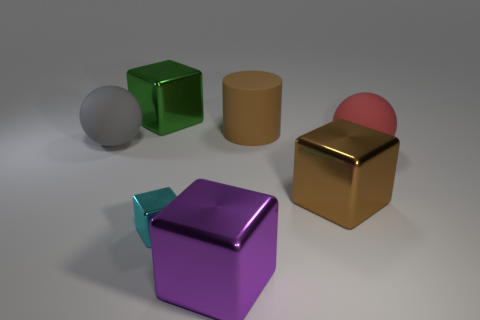Add 3 cyan metal things. How many objects exist? 10 Subtract all balls. How many objects are left? 5 Subtract 0 yellow spheres. How many objects are left? 7 Subtract all gray rubber things. Subtract all brown shiny things. How many objects are left? 5 Add 5 brown shiny blocks. How many brown shiny blocks are left? 6 Add 3 big cyan rubber blocks. How many big cyan rubber blocks exist? 3 